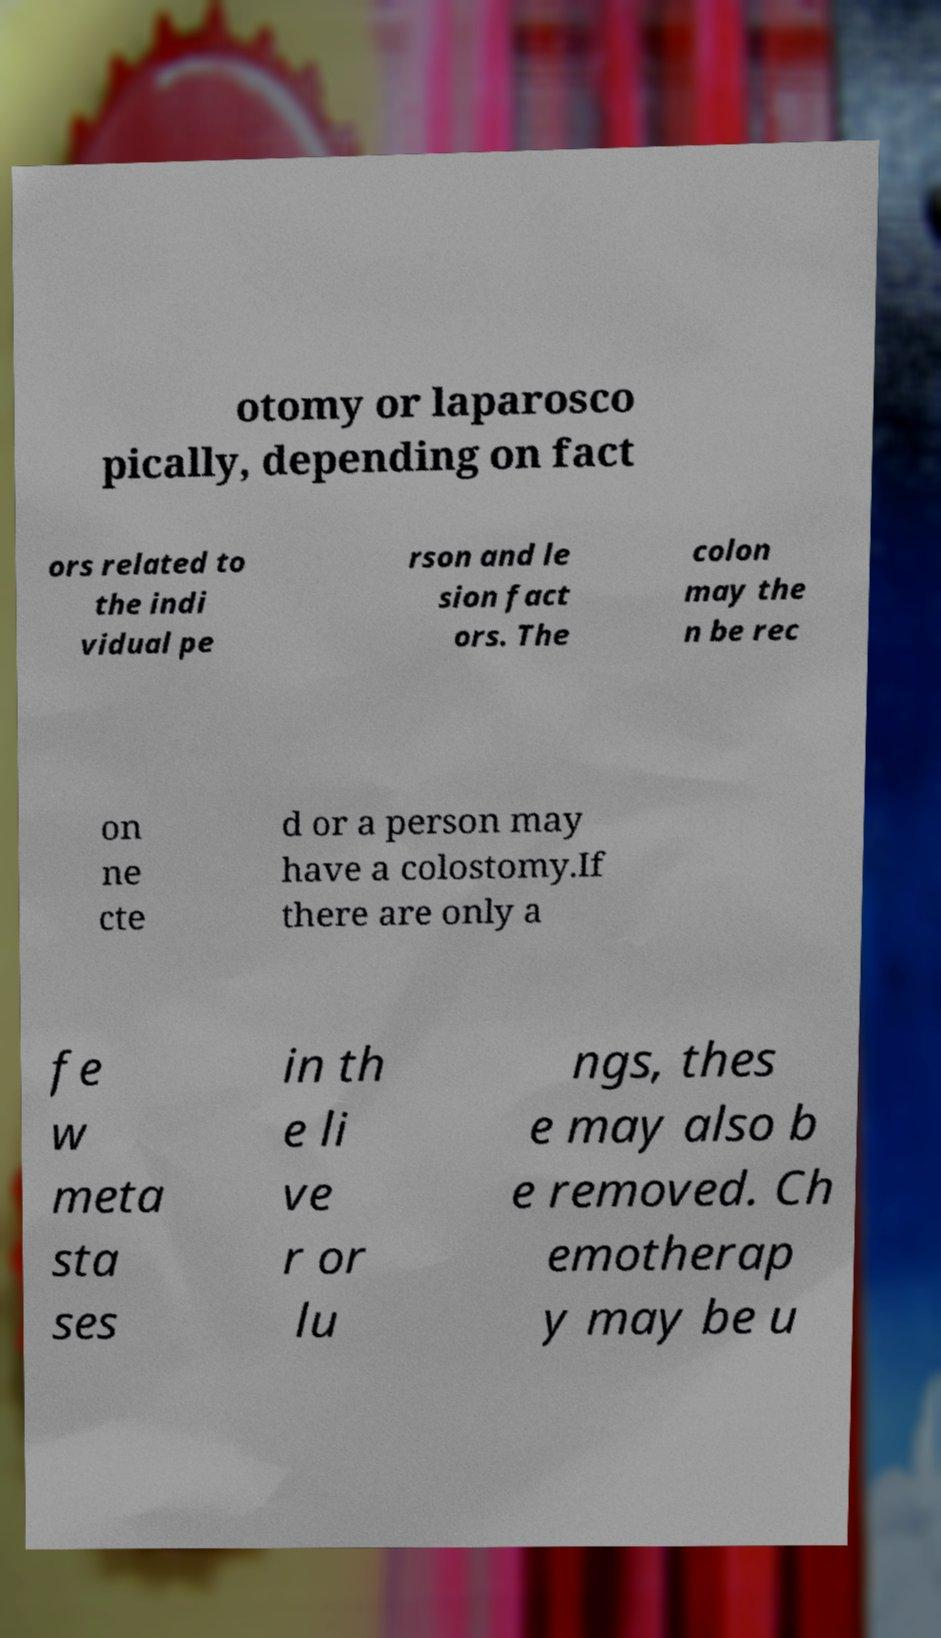Can you read and provide the text displayed in the image?This photo seems to have some interesting text. Can you extract and type it out for me? otomy or laparosco pically, depending on fact ors related to the indi vidual pe rson and le sion fact ors. The colon may the n be rec on ne cte d or a person may have a colostomy.If there are only a fe w meta sta ses in th e li ve r or lu ngs, thes e may also b e removed. Ch emotherap y may be u 